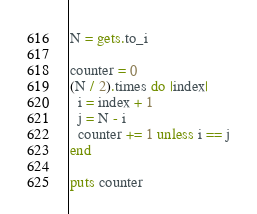Convert code to text. <code><loc_0><loc_0><loc_500><loc_500><_Ruby_>N = gets.to_i

counter = 0
(N / 2).times do |index|
  i = index + 1
  j = N - i
  counter += 1 unless i == j
end

puts counter</code> 